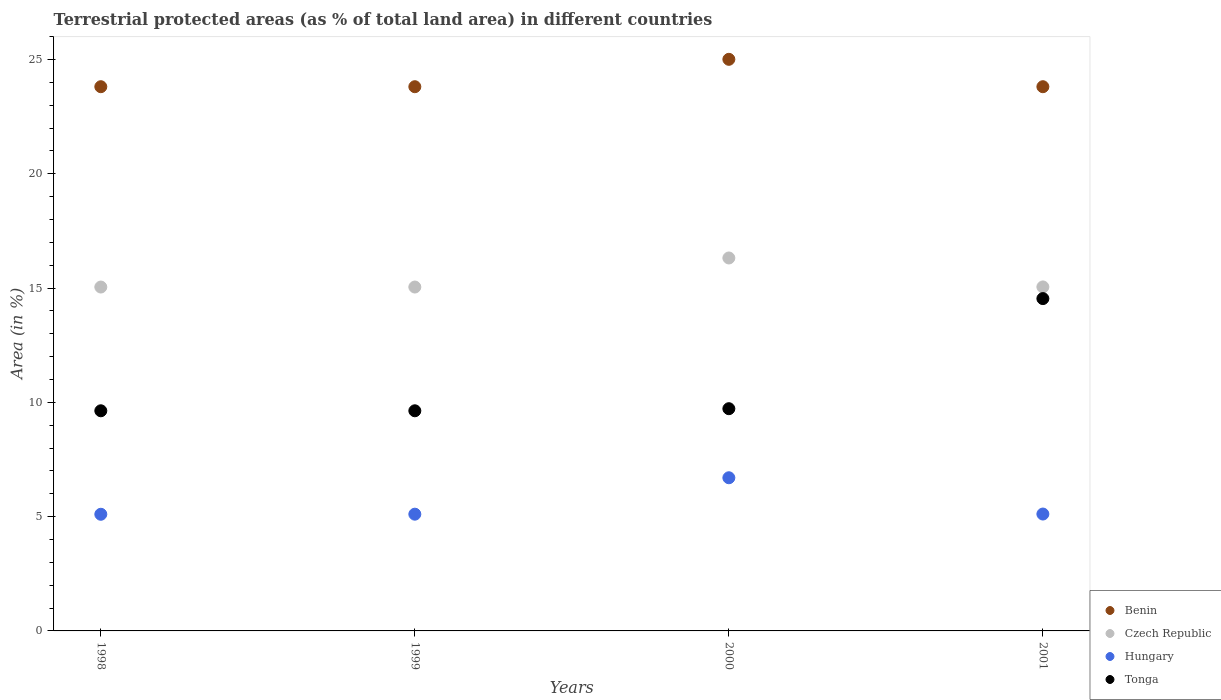How many different coloured dotlines are there?
Your answer should be compact. 4. What is the percentage of terrestrial protected land in Hungary in 1998?
Provide a short and direct response. 5.1. Across all years, what is the maximum percentage of terrestrial protected land in Tonga?
Provide a succinct answer. 14.54. Across all years, what is the minimum percentage of terrestrial protected land in Czech Republic?
Offer a terse response. 15.04. In which year was the percentage of terrestrial protected land in Benin maximum?
Offer a terse response. 2000. In which year was the percentage of terrestrial protected land in Czech Republic minimum?
Provide a succinct answer. 1998. What is the total percentage of terrestrial protected land in Hungary in the graph?
Provide a short and direct response. 22.02. What is the difference between the percentage of terrestrial protected land in Hungary in 1998 and that in 1999?
Your answer should be very brief. -0. What is the difference between the percentage of terrestrial protected land in Czech Republic in 1999 and the percentage of terrestrial protected land in Tonga in 2001?
Keep it short and to the point. 0.51. What is the average percentage of terrestrial protected land in Tonga per year?
Provide a succinct answer. 10.88. In the year 1999, what is the difference between the percentage of terrestrial protected land in Hungary and percentage of terrestrial protected land in Czech Republic?
Provide a short and direct response. -9.94. What is the ratio of the percentage of terrestrial protected land in Hungary in 1999 to that in 2001?
Offer a terse response. 1. Is the percentage of terrestrial protected land in Hungary in 1999 less than that in 2000?
Make the answer very short. Yes. Is the difference between the percentage of terrestrial protected land in Hungary in 1998 and 1999 greater than the difference between the percentage of terrestrial protected land in Czech Republic in 1998 and 1999?
Provide a short and direct response. No. What is the difference between the highest and the second highest percentage of terrestrial protected land in Hungary?
Ensure brevity in your answer.  1.59. What is the difference between the highest and the lowest percentage of terrestrial protected land in Tonga?
Offer a very short reply. 4.91. Is it the case that in every year, the sum of the percentage of terrestrial protected land in Tonga and percentage of terrestrial protected land in Benin  is greater than the sum of percentage of terrestrial protected land in Czech Republic and percentage of terrestrial protected land in Hungary?
Offer a very short reply. Yes. Is it the case that in every year, the sum of the percentage of terrestrial protected land in Hungary and percentage of terrestrial protected land in Tonga  is greater than the percentage of terrestrial protected land in Czech Republic?
Offer a very short reply. No. Is the percentage of terrestrial protected land in Tonga strictly less than the percentage of terrestrial protected land in Benin over the years?
Offer a terse response. Yes. How many dotlines are there?
Ensure brevity in your answer.  4. Does the graph contain any zero values?
Your answer should be compact. No. Does the graph contain grids?
Provide a succinct answer. No. Where does the legend appear in the graph?
Your response must be concise. Bottom right. How many legend labels are there?
Offer a very short reply. 4. How are the legend labels stacked?
Give a very brief answer. Vertical. What is the title of the graph?
Keep it short and to the point. Terrestrial protected areas (as % of total land area) in different countries. What is the label or title of the X-axis?
Offer a very short reply. Years. What is the label or title of the Y-axis?
Ensure brevity in your answer.  Area (in %). What is the Area (in %) of Benin in 1998?
Give a very brief answer. 23.81. What is the Area (in %) of Czech Republic in 1998?
Provide a short and direct response. 15.04. What is the Area (in %) in Hungary in 1998?
Your answer should be very brief. 5.1. What is the Area (in %) of Tonga in 1998?
Your response must be concise. 9.63. What is the Area (in %) of Benin in 1999?
Offer a very short reply. 23.81. What is the Area (in %) of Czech Republic in 1999?
Ensure brevity in your answer.  15.04. What is the Area (in %) in Hungary in 1999?
Provide a short and direct response. 5.11. What is the Area (in %) of Tonga in 1999?
Offer a terse response. 9.63. What is the Area (in %) in Benin in 2000?
Your response must be concise. 25.01. What is the Area (in %) of Czech Republic in 2000?
Your response must be concise. 16.32. What is the Area (in %) of Hungary in 2000?
Ensure brevity in your answer.  6.7. What is the Area (in %) in Tonga in 2000?
Give a very brief answer. 9.72. What is the Area (in %) in Benin in 2001?
Provide a short and direct response. 23.81. What is the Area (in %) in Czech Republic in 2001?
Offer a terse response. 15.05. What is the Area (in %) in Hungary in 2001?
Offer a terse response. 5.11. What is the Area (in %) in Tonga in 2001?
Provide a short and direct response. 14.54. Across all years, what is the maximum Area (in %) of Benin?
Provide a short and direct response. 25.01. Across all years, what is the maximum Area (in %) of Czech Republic?
Give a very brief answer. 16.32. Across all years, what is the maximum Area (in %) in Hungary?
Provide a succinct answer. 6.7. Across all years, what is the maximum Area (in %) of Tonga?
Keep it short and to the point. 14.54. Across all years, what is the minimum Area (in %) of Benin?
Make the answer very short. 23.81. Across all years, what is the minimum Area (in %) in Czech Republic?
Provide a succinct answer. 15.04. Across all years, what is the minimum Area (in %) of Hungary?
Offer a very short reply. 5.1. Across all years, what is the minimum Area (in %) of Tonga?
Offer a very short reply. 9.63. What is the total Area (in %) of Benin in the graph?
Make the answer very short. 96.43. What is the total Area (in %) of Czech Republic in the graph?
Offer a very short reply. 61.45. What is the total Area (in %) of Hungary in the graph?
Provide a succinct answer. 22.02. What is the total Area (in %) of Tonga in the graph?
Your answer should be very brief. 43.52. What is the difference between the Area (in %) of Czech Republic in 1998 and that in 1999?
Offer a terse response. 0. What is the difference between the Area (in %) of Hungary in 1998 and that in 1999?
Offer a terse response. -0. What is the difference between the Area (in %) of Benin in 1998 and that in 2000?
Make the answer very short. -1.2. What is the difference between the Area (in %) in Czech Republic in 1998 and that in 2000?
Your answer should be compact. -1.27. What is the difference between the Area (in %) of Hungary in 1998 and that in 2000?
Give a very brief answer. -1.6. What is the difference between the Area (in %) of Tonga in 1998 and that in 2000?
Make the answer very short. -0.09. What is the difference between the Area (in %) in Benin in 1998 and that in 2001?
Your answer should be compact. 0. What is the difference between the Area (in %) of Czech Republic in 1998 and that in 2001?
Your answer should be very brief. -0.01. What is the difference between the Area (in %) of Hungary in 1998 and that in 2001?
Offer a very short reply. -0.01. What is the difference between the Area (in %) of Tonga in 1998 and that in 2001?
Your response must be concise. -4.91. What is the difference between the Area (in %) in Benin in 1999 and that in 2000?
Ensure brevity in your answer.  -1.2. What is the difference between the Area (in %) of Czech Republic in 1999 and that in 2000?
Ensure brevity in your answer.  -1.27. What is the difference between the Area (in %) of Hungary in 1999 and that in 2000?
Your response must be concise. -1.59. What is the difference between the Area (in %) of Tonga in 1999 and that in 2000?
Your response must be concise. -0.09. What is the difference between the Area (in %) in Czech Republic in 1999 and that in 2001?
Your answer should be very brief. -0.01. What is the difference between the Area (in %) in Hungary in 1999 and that in 2001?
Ensure brevity in your answer.  -0.01. What is the difference between the Area (in %) of Tonga in 1999 and that in 2001?
Ensure brevity in your answer.  -4.91. What is the difference between the Area (in %) in Benin in 2000 and that in 2001?
Keep it short and to the point. 1.2. What is the difference between the Area (in %) of Czech Republic in 2000 and that in 2001?
Keep it short and to the point. 1.27. What is the difference between the Area (in %) of Hungary in 2000 and that in 2001?
Offer a terse response. 1.59. What is the difference between the Area (in %) in Tonga in 2000 and that in 2001?
Give a very brief answer. -4.82. What is the difference between the Area (in %) in Benin in 1998 and the Area (in %) in Czech Republic in 1999?
Provide a short and direct response. 8.76. What is the difference between the Area (in %) in Benin in 1998 and the Area (in %) in Hungary in 1999?
Provide a short and direct response. 18.7. What is the difference between the Area (in %) in Benin in 1998 and the Area (in %) in Tonga in 1999?
Ensure brevity in your answer.  14.18. What is the difference between the Area (in %) in Czech Republic in 1998 and the Area (in %) in Hungary in 1999?
Give a very brief answer. 9.94. What is the difference between the Area (in %) of Czech Republic in 1998 and the Area (in %) of Tonga in 1999?
Give a very brief answer. 5.41. What is the difference between the Area (in %) in Hungary in 1998 and the Area (in %) in Tonga in 1999?
Ensure brevity in your answer.  -4.53. What is the difference between the Area (in %) in Benin in 1998 and the Area (in %) in Czech Republic in 2000?
Your answer should be very brief. 7.49. What is the difference between the Area (in %) in Benin in 1998 and the Area (in %) in Hungary in 2000?
Offer a terse response. 17.11. What is the difference between the Area (in %) of Benin in 1998 and the Area (in %) of Tonga in 2000?
Provide a succinct answer. 14.09. What is the difference between the Area (in %) of Czech Republic in 1998 and the Area (in %) of Hungary in 2000?
Offer a terse response. 8.34. What is the difference between the Area (in %) of Czech Republic in 1998 and the Area (in %) of Tonga in 2000?
Your response must be concise. 5.32. What is the difference between the Area (in %) in Hungary in 1998 and the Area (in %) in Tonga in 2000?
Make the answer very short. -4.62. What is the difference between the Area (in %) of Benin in 1998 and the Area (in %) of Czech Republic in 2001?
Provide a succinct answer. 8.76. What is the difference between the Area (in %) in Benin in 1998 and the Area (in %) in Hungary in 2001?
Give a very brief answer. 18.69. What is the difference between the Area (in %) in Benin in 1998 and the Area (in %) in Tonga in 2001?
Keep it short and to the point. 9.27. What is the difference between the Area (in %) in Czech Republic in 1998 and the Area (in %) in Hungary in 2001?
Your response must be concise. 9.93. What is the difference between the Area (in %) of Czech Republic in 1998 and the Area (in %) of Tonga in 2001?
Provide a succinct answer. 0.51. What is the difference between the Area (in %) in Hungary in 1998 and the Area (in %) in Tonga in 2001?
Offer a very short reply. -9.44. What is the difference between the Area (in %) in Benin in 1999 and the Area (in %) in Czech Republic in 2000?
Ensure brevity in your answer.  7.49. What is the difference between the Area (in %) in Benin in 1999 and the Area (in %) in Hungary in 2000?
Offer a terse response. 17.11. What is the difference between the Area (in %) of Benin in 1999 and the Area (in %) of Tonga in 2000?
Provide a short and direct response. 14.09. What is the difference between the Area (in %) of Czech Republic in 1999 and the Area (in %) of Hungary in 2000?
Offer a terse response. 8.34. What is the difference between the Area (in %) of Czech Republic in 1999 and the Area (in %) of Tonga in 2000?
Your answer should be compact. 5.32. What is the difference between the Area (in %) of Hungary in 1999 and the Area (in %) of Tonga in 2000?
Your response must be concise. -4.61. What is the difference between the Area (in %) in Benin in 1999 and the Area (in %) in Czech Republic in 2001?
Make the answer very short. 8.76. What is the difference between the Area (in %) in Benin in 1999 and the Area (in %) in Hungary in 2001?
Offer a very short reply. 18.69. What is the difference between the Area (in %) in Benin in 1999 and the Area (in %) in Tonga in 2001?
Offer a terse response. 9.27. What is the difference between the Area (in %) of Czech Republic in 1999 and the Area (in %) of Hungary in 2001?
Your response must be concise. 9.93. What is the difference between the Area (in %) of Czech Republic in 1999 and the Area (in %) of Tonga in 2001?
Offer a terse response. 0.51. What is the difference between the Area (in %) in Hungary in 1999 and the Area (in %) in Tonga in 2001?
Your answer should be compact. -9.43. What is the difference between the Area (in %) in Benin in 2000 and the Area (in %) in Czech Republic in 2001?
Give a very brief answer. 9.96. What is the difference between the Area (in %) of Benin in 2000 and the Area (in %) of Hungary in 2001?
Your answer should be compact. 19.89. What is the difference between the Area (in %) in Benin in 2000 and the Area (in %) in Tonga in 2001?
Provide a succinct answer. 10.47. What is the difference between the Area (in %) in Czech Republic in 2000 and the Area (in %) in Hungary in 2001?
Your answer should be compact. 11.2. What is the difference between the Area (in %) of Czech Republic in 2000 and the Area (in %) of Tonga in 2001?
Give a very brief answer. 1.78. What is the difference between the Area (in %) of Hungary in 2000 and the Area (in %) of Tonga in 2001?
Ensure brevity in your answer.  -7.84. What is the average Area (in %) of Benin per year?
Keep it short and to the point. 24.11. What is the average Area (in %) of Czech Republic per year?
Give a very brief answer. 15.36. What is the average Area (in %) of Hungary per year?
Make the answer very short. 5.51. What is the average Area (in %) in Tonga per year?
Your answer should be very brief. 10.88. In the year 1998, what is the difference between the Area (in %) of Benin and Area (in %) of Czech Republic?
Offer a very short reply. 8.76. In the year 1998, what is the difference between the Area (in %) of Benin and Area (in %) of Hungary?
Your response must be concise. 18.7. In the year 1998, what is the difference between the Area (in %) in Benin and Area (in %) in Tonga?
Provide a succinct answer. 14.18. In the year 1998, what is the difference between the Area (in %) in Czech Republic and Area (in %) in Hungary?
Your answer should be compact. 9.94. In the year 1998, what is the difference between the Area (in %) of Czech Republic and Area (in %) of Tonga?
Your answer should be compact. 5.41. In the year 1998, what is the difference between the Area (in %) of Hungary and Area (in %) of Tonga?
Offer a terse response. -4.53. In the year 1999, what is the difference between the Area (in %) in Benin and Area (in %) in Czech Republic?
Your answer should be compact. 8.76. In the year 1999, what is the difference between the Area (in %) in Benin and Area (in %) in Hungary?
Provide a short and direct response. 18.7. In the year 1999, what is the difference between the Area (in %) of Benin and Area (in %) of Tonga?
Provide a succinct answer. 14.18. In the year 1999, what is the difference between the Area (in %) of Czech Republic and Area (in %) of Hungary?
Your answer should be compact. 9.94. In the year 1999, what is the difference between the Area (in %) in Czech Republic and Area (in %) in Tonga?
Provide a short and direct response. 5.41. In the year 1999, what is the difference between the Area (in %) in Hungary and Area (in %) in Tonga?
Make the answer very short. -4.52. In the year 2000, what is the difference between the Area (in %) of Benin and Area (in %) of Czech Republic?
Give a very brief answer. 8.69. In the year 2000, what is the difference between the Area (in %) of Benin and Area (in %) of Hungary?
Offer a terse response. 18.3. In the year 2000, what is the difference between the Area (in %) of Benin and Area (in %) of Tonga?
Provide a short and direct response. 15.28. In the year 2000, what is the difference between the Area (in %) in Czech Republic and Area (in %) in Hungary?
Ensure brevity in your answer.  9.61. In the year 2000, what is the difference between the Area (in %) of Czech Republic and Area (in %) of Tonga?
Offer a very short reply. 6.59. In the year 2000, what is the difference between the Area (in %) of Hungary and Area (in %) of Tonga?
Your answer should be compact. -3.02. In the year 2001, what is the difference between the Area (in %) of Benin and Area (in %) of Czech Republic?
Provide a short and direct response. 8.76. In the year 2001, what is the difference between the Area (in %) of Benin and Area (in %) of Hungary?
Provide a short and direct response. 18.69. In the year 2001, what is the difference between the Area (in %) of Benin and Area (in %) of Tonga?
Give a very brief answer. 9.27. In the year 2001, what is the difference between the Area (in %) of Czech Republic and Area (in %) of Hungary?
Your answer should be very brief. 9.94. In the year 2001, what is the difference between the Area (in %) of Czech Republic and Area (in %) of Tonga?
Your response must be concise. 0.51. In the year 2001, what is the difference between the Area (in %) in Hungary and Area (in %) in Tonga?
Provide a succinct answer. -9.42. What is the ratio of the Area (in %) of Hungary in 1998 to that in 1999?
Your answer should be very brief. 1. What is the ratio of the Area (in %) of Tonga in 1998 to that in 1999?
Ensure brevity in your answer.  1. What is the ratio of the Area (in %) of Benin in 1998 to that in 2000?
Your response must be concise. 0.95. What is the ratio of the Area (in %) in Czech Republic in 1998 to that in 2000?
Keep it short and to the point. 0.92. What is the ratio of the Area (in %) in Hungary in 1998 to that in 2000?
Keep it short and to the point. 0.76. What is the ratio of the Area (in %) of Tonga in 1998 to that in 2000?
Provide a succinct answer. 0.99. What is the ratio of the Area (in %) of Czech Republic in 1998 to that in 2001?
Your response must be concise. 1. What is the ratio of the Area (in %) in Tonga in 1998 to that in 2001?
Keep it short and to the point. 0.66. What is the ratio of the Area (in %) of Benin in 1999 to that in 2000?
Make the answer very short. 0.95. What is the ratio of the Area (in %) of Czech Republic in 1999 to that in 2000?
Make the answer very short. 0.92. What is the ratio of the Area (in %) in Hungary in 1999 to that in 2000?
Keep it short and to the point. 0.76. What is the ratio of the Area (in %) in Tonga in 1999 to that in 2000?
Keep it short and to the point. 0.99. What is the ratio of the Area (in %) in Benin in 1999 to that in 2001?
Keep it short and to the point. 1. What is the ratio of the Area (in %) of Hungary in 1999 to that in 2001?
Your answer should be very brief. 1. What is the ratio of the Area (in %) in Tonga in 1999 to that in 2001?
Provide a short and direct response. 0.66. What is the ratio of the Area (in %) of Benin in 2000 to that in 2001?
Your response must be concise. 1.05. What is the ratio of the Area (in %) in Czech Republic in 2000 to that in 2001?
Provide a short and direct response. 1.08. What is the ratio of the Area (in %) of Hungary in 2000 to that in 2001?
Offer a terse response. 1.31. What is the ratio of the Area (in %) in Tonga in 2000 to that in 2001?
Your response must be concise. 0.67. What is the difference between the highest and the second highest Area (in %) of Benin?
Offer a terse response. 1.2. What is the difference between the highest and the second highest Area (in %) of Czech Republic?
Offer a terse response. 1.27. What is the difference between the highest and the second highest Area (in %) of Hungary?
Ensure brevity in your answer.  1.59. What is the difference between the highest and the second highest Area (in %) in Tonga?
Make the answer very short. 4.82. What is the difference between the highest and the lowest Area (in %) of Benin?
Provide a succinct answer. 1.2. What is the difference between the highest and the lowest Area (in %) of Czech Republic?
Offer a very short reply. 1.27. What is the difference between the highest and the lowest Area (in %) of Hungary?
Offer a terse response. 1.6. What is the difference between the highest and the lowest Area (in %) of Tonga?
Make the answer very short. 4.91. 